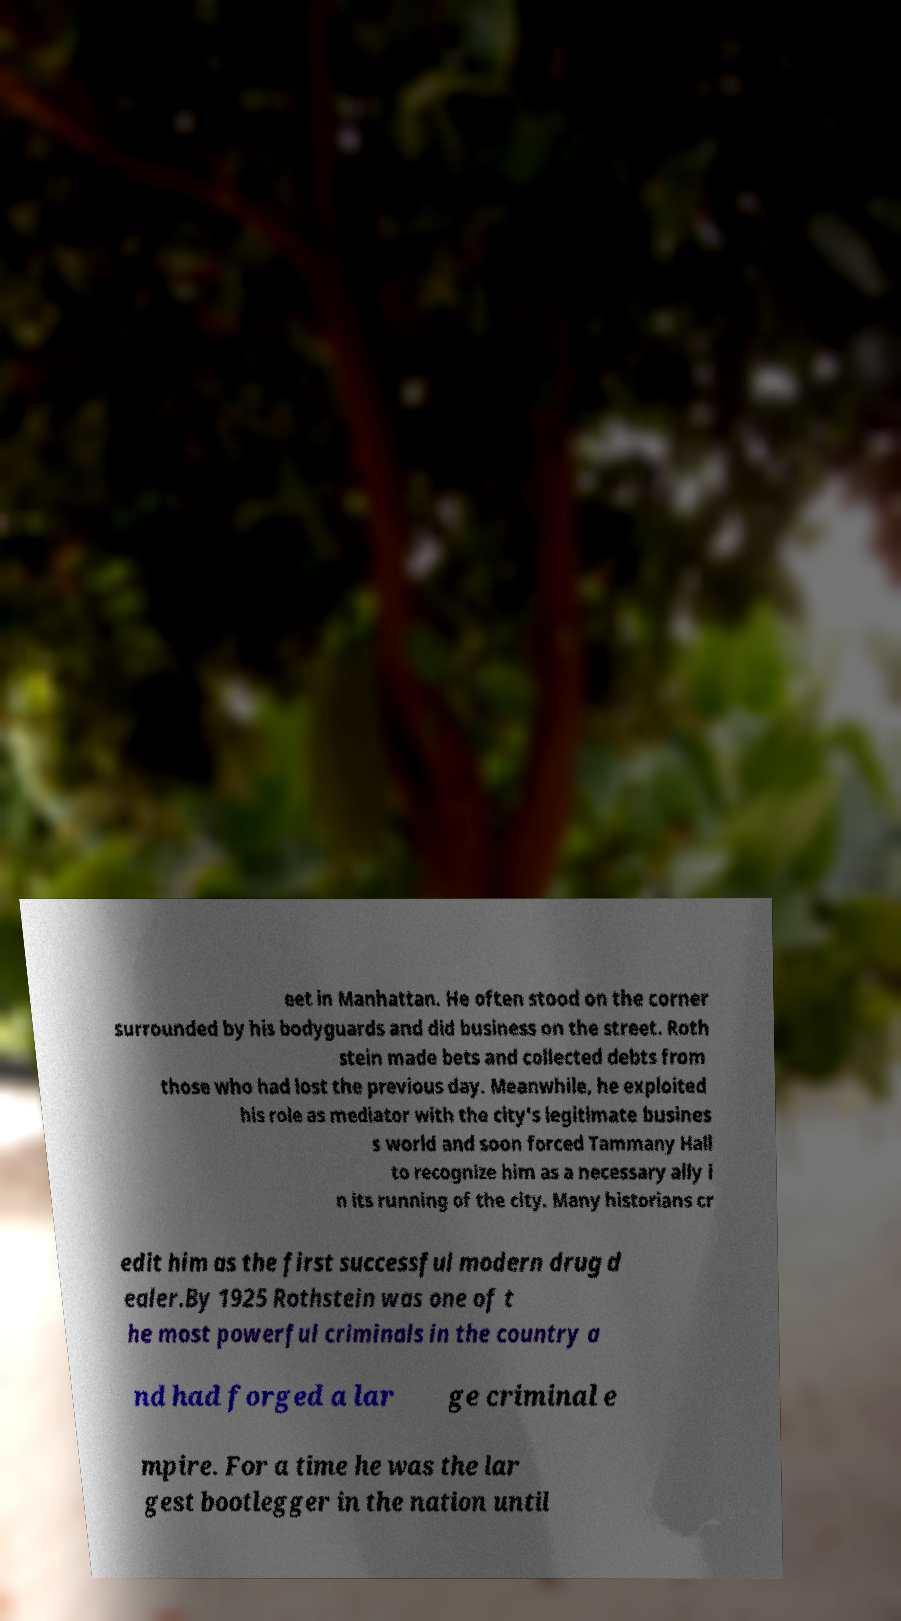Could you extract and type out the text from this image? eet in Manhattan. He often stood on the corner surrounded by his bodyguards and did business on the street. Roth stein made bets and collected debts from those who had lost the previous day. Meanwhile, he exploited his role as mediator with the city's legitimate busines s world and soon forced Tammany Hall to recognize him as a necessary ally i n its running of the city. Many historians cr edit him as the first successful modern drug d ealer.By 1925 Rothstein was one of t he most powerful criminals in the country a nd had forged a lar ge criminal e mpire. For a time he was the lar gest bootlegger in the nation until 